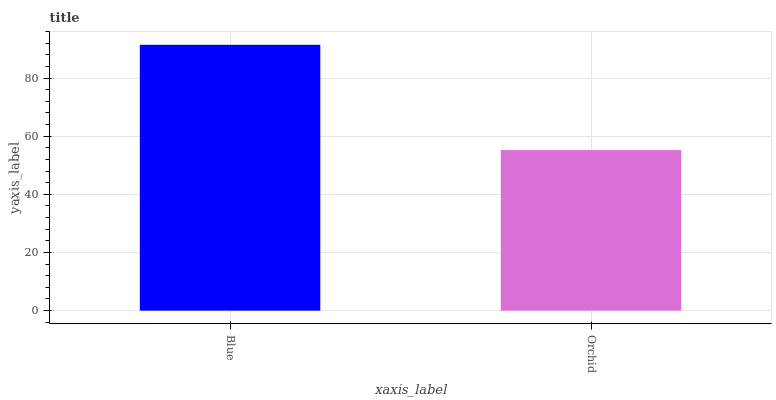Is Orchid the minimum?
Answer yes or no. Yes. Is Blue the maximum?
Answer yes or no. Yes. Is Orchid the maximum?
Answer yes or no. No. Is Blue greater than Orchid?
Answer yes or no. Yes. Is Orchid less than Blue?
Answer yes or no. Yes. Is Orchid greater than Blue?
Answer yes or no. No. Is Blue less than Orchid?
Answer yes or no. No. Is Blue the high median?
Answer yes or no. Yes. Is Orchid the low median?
Answer yes or no. Yes. Is Orchid the high median?
Answer yes or no. No. Is Blue the low median?
Answer yes or no. No. 